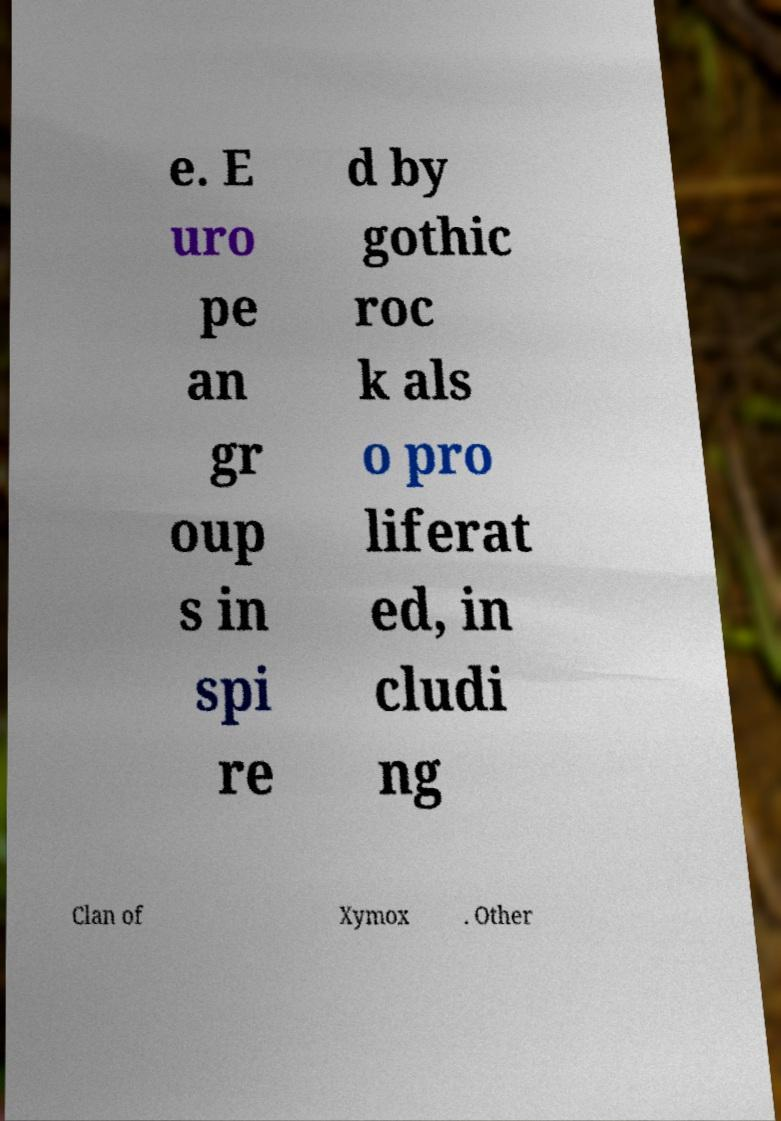Could you assist in decoding the text presented in this image and type it out clearly? e. E uro pe an gr oup s in spi re d by gothic roc k als o pro liferat ed, in cludi ng Clan of Xymox . Other 